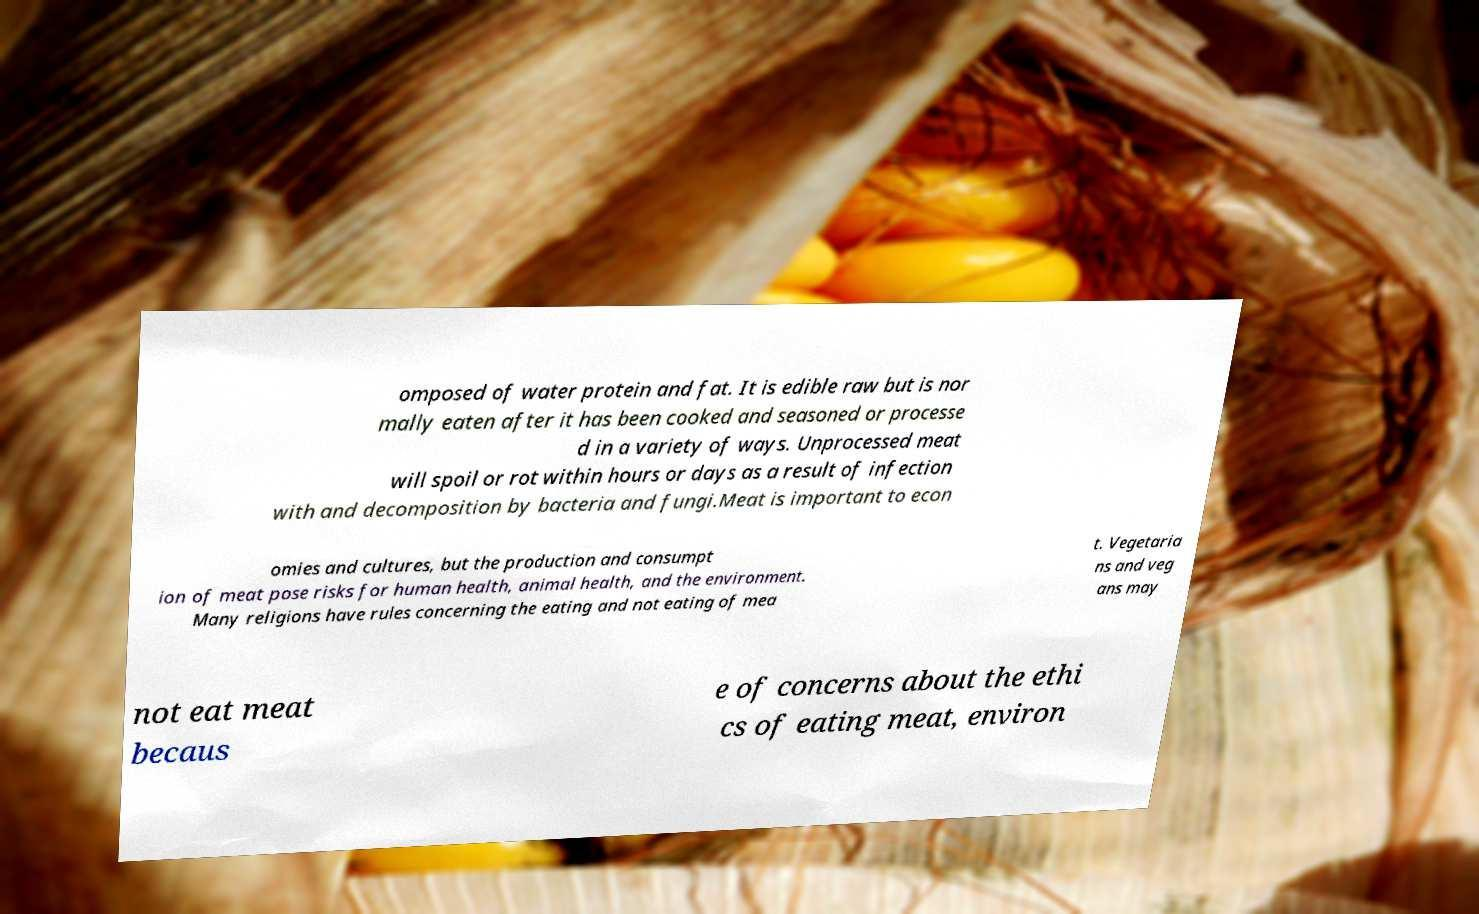For documentation purposes, I need the text within this image transcribed. Could you provide that? omposed of water protein and fat. It is edible raw but is nor mally eaten after it has been cooked and seasoned or processe d in a variety of ways. Unprocessed meat will spoil or rot within hours or days as a result of infection with and decomposition by bacteria and fungi.Meat is important to econ omies and cultures, but the production and consumpt ion of meat pose risks for human health, animal health, and the environment. Many religions have rules concerning the eating and not eating of mea t. Vegetaria ns and veg ans may not eat meat becaus e of concerns about the ethi cs of eating meat, environ 